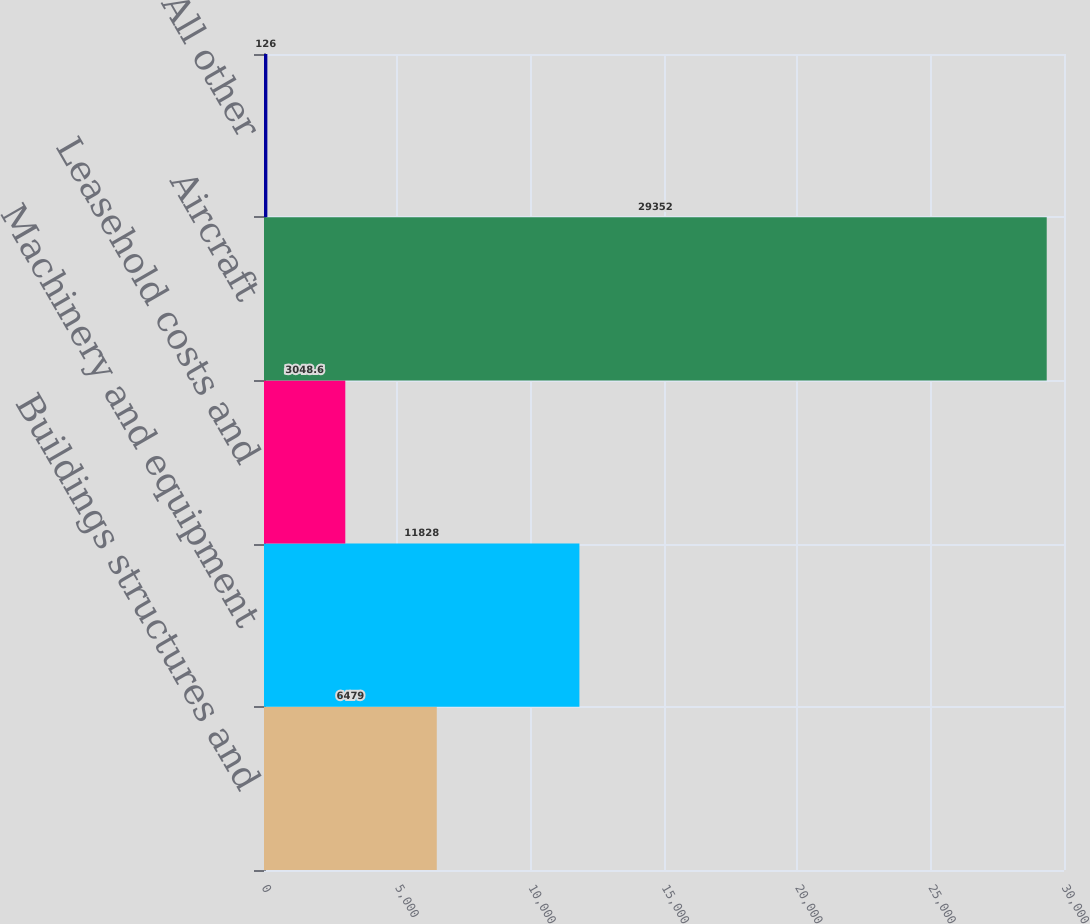<chart> <loc_0><loc_0><loc_500><loc_500><bar_chart><fcel>Buildings structures and<fcel>Machinery and equipment<fcel>Leasehold costs and<fcel>Aircraft<fcel>All other<nl><fcel>6479<fcel>11828<fcel>3048.6<fcel>29352<fcel>126<nl></chart> 